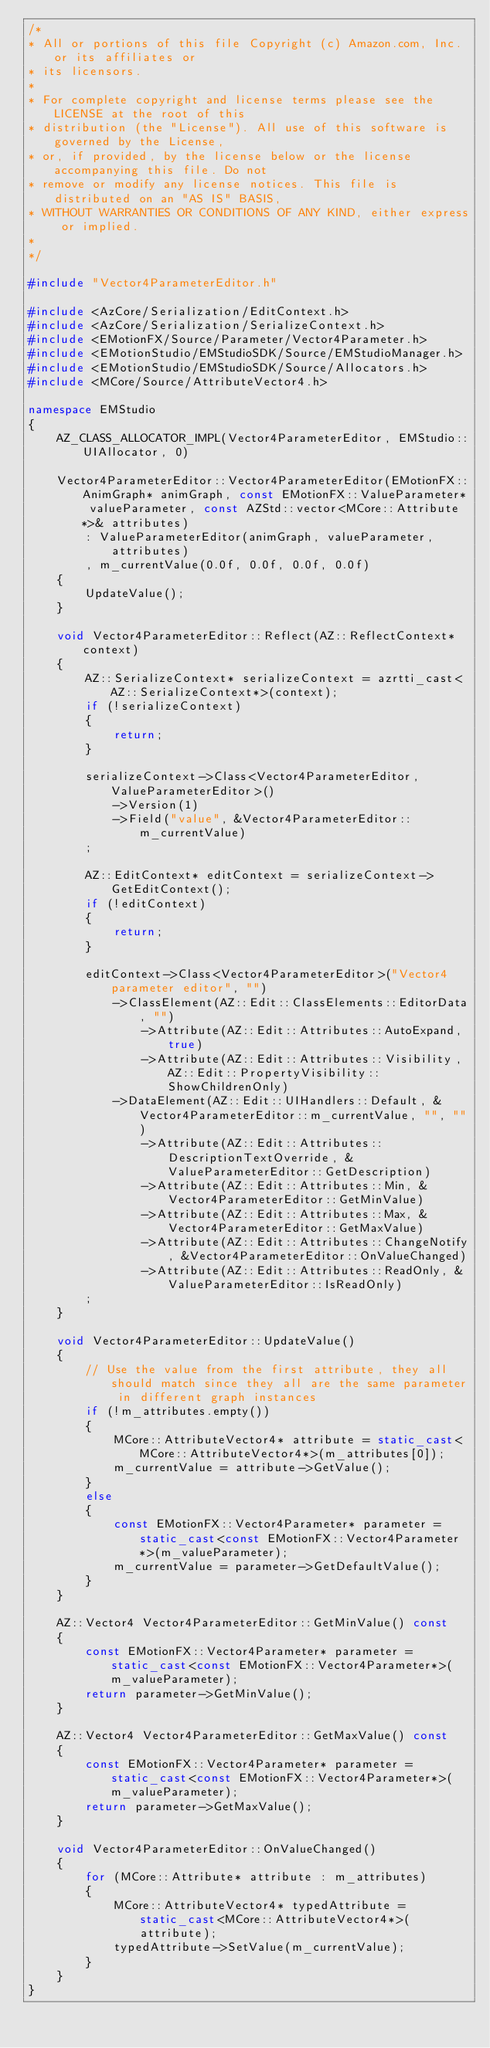Convert code to text. <code><loc_0><loc_0><loc_500><loc_500><_C++_>/*
* All or portions of this file Copyright (c) Amazon.com, Inc. or its affiliates or
* its licensors.
*
* For complete copyright and license terms please see the LICENSE at the root of this
* distribution (the "License"). All use of this software is governed by the License,
* or, if provided, by the license below or the license accompanying this file. Do not
* remove or modify any license notices. This file is distributed on an "AS IS" BASIS,
* WITHOUT WARRANTIES OR CONDITIONS OF ANY KIND, either express or implied.
*
*/

#include "Vector4ParameterEditor.h"

#include <AzCore/Serialization/EditContext.h>
#include <AzCore/Serialization/SerializeContext.h>
#include <EMotionFX/Source/Parameter/Vector4Parameter.h>
#include <EMotionStudio/EMStudioSDK/Source/EMStudioManager.h>
#include <EMotionStudio/EMStudioSDK/Source/Allocators.h>
#include <MCore/Source/AttributeVector4.h>

namespace EMStudio
{
    AZ_CLASS_ALLOCATOR_IMPL(Vector4ParameterEditor, EMStudio::UIAllocator, 0)

    Vector4ParameterEditor::Vector4ParameterEditor(EMotionFX::AnimGraph* animGraph, const EMotionFX::ValueParameter* valueParameter, const AZStd::vector<MCore::Attribute*>& attributes)
        : ValueParameterEditor(animGraph, valueParameter, attributes)
        , m_currentValue(0.0f, 0.0f, 0.0f, 0.0f)
    {
        UpdateValue();
    }

    void Vector4ParameterEditor::Reflect(AZ::ReflectContext* context)
    {
        AZ::SerializeContext* serializeContext = azrtti_cast<AZ::SerializeContext*>(context);
        if (!serializeContext)
        {
            return;
        }

        serializeContext->Class<Vector4ParameterEditor, ValueParameterEditor>()
            ->Version(1)
            ->Field("value", &Vector4ParameterEditor::m_currentValue)
        ;

        AZ::EditContext* editContext = serializeContext->GetEditContext();
        if (!editContext)
        {
            return;
        }

        editContext->Class<Vector4ParameterEditor>("Vector4 parameter editor", "")
            ->ClassElement(AZ::Edit::ClassElements::EditorData, "")
                ->Attribute(AZ::Edit::Attributes::AutoExpand, true)
                ->Attribute(AZ::Edit::Attributes::Visibility, AZ::Edit::PropertyVisibility::ShowChildrenOnly)
            ->DataElement(AZ::Edit::UIHandlers::Default, &Vector4ParameterEditor::m_currentValue, "", "")
                ->Attribute(AZ::Edit::Attributes::DescriptionTextOverride, &ValueParameterEditor::GetDescription)
                ->Attribute(AZ::Edit::Attributes::Min, &Vector4ParameterEditor::GetMinValue)
                ->Attribute(AZ::Edit::Attributes::Max, &Vector4ParameterEditor::GetMaxValue)
                ->Attribute(AZ::Edit::Attributes::ChangeNotify, &Vector4ParameterEditor::OnValueChanged)
                ->Attribute(AZ::Edit::Attributes::ReadOnly, &ValueParameterEditor::IsReadOnly)
        ;
    }

    void Vector4ParameterEditor::UpdateValue()
    {
        // Use the value from the first attribute, they all should match since they all are the same parameter in different graph instances
        if (!m_attributes.empty())
        {
            MCore::AttributeVector4* attribute = static_cast<MCore::AttributeVector4*>(m_attributes[0]);
            m_currentValue = attribute->GetValue();
        }
        else
        {
            const EMotionFX::Vector4Parameter* parameter = static_cast<const EMotionFX::Vector4Parameter*>(m_valueParameter);
            m_currentValue = parameter->GetDefaultValue();
        }
    }

    AZ::Vector4 Vector4ParameterEditor::GetMinValue() const
    {
        const EMotionFX::Vector4Parameter* parameter = static_cast<const EMotionFX::Vector4Parameter*>(m_valueParameter);
        return parameter->GetMinValue();
    }

    AZ::Vector4 Vector4ParameterEditor::GetMaxValue() const
    {
        const EMotionFX::Vector4Parameter* parameter = static_cast<const EMotionFX::Vector4Parameter*>(m_valueParameter);
        return parameter->GetMaxValue();
    }

    void Vector4ParameterEditor::OnValueChanged()
    {
        for (MCore::Attribute* attribute : m_attributes)
        {
            MCore::AttributeVector4* typedAttribute = static_cast<MCore::AttributeVector4*>(attribute);
            typedAttribute->SetValue(m_currentValue);
        }
    }
}
</code> 